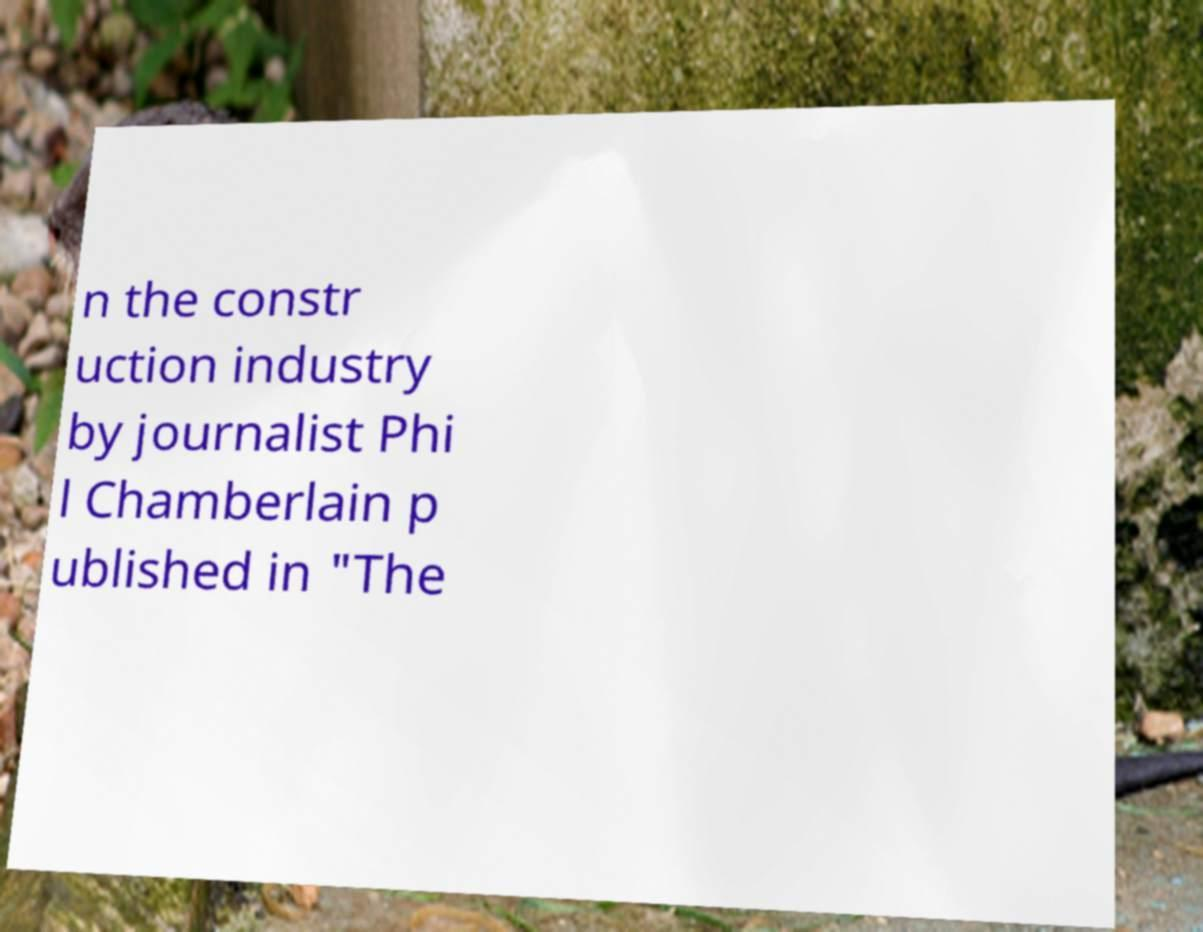There's text embedded in this image that I need extracted. Can you transcribe it verbatim? n the constr uction industry by journalist Phi l Chamberlain p ublished in "The 